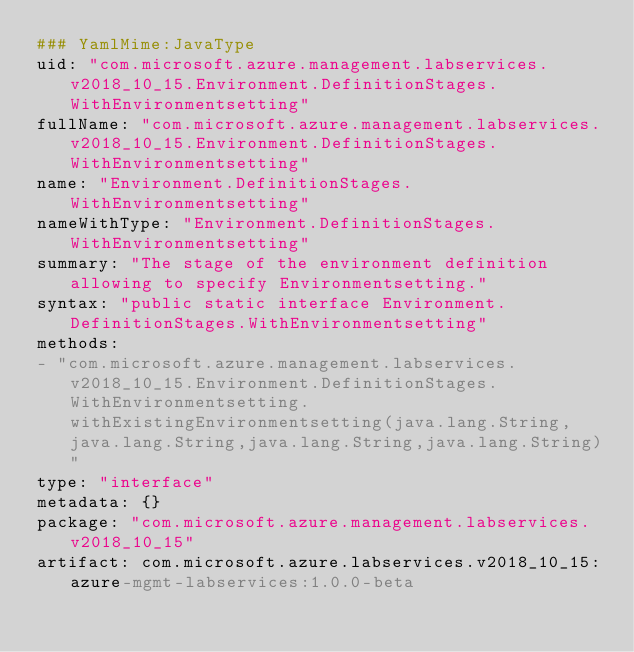<code> <loc_0><loc_0><loc_500><loc_500><_YAML_>### YamlMime:JavaType
uid: "com.microsoft.azure.management.labservices.v2018_10_15.Environment.DefinitionStages.WithEnvironmentsetting"
fullName: "com.microsoft.azure.management.labservices.v2018_10_15.Environment.DefinitionStages.WithEnvironmentsetting"
name: "Environment.DefinitionStages.WithEnvironmentsetting"
nameWithType: "Environment.DefinitionStages.WithEnvironmentsetting"
summary: "The stage of the environment definition allowing to specify Environmentsetting."
syntax: "public static interface Environment.DefinitionStages.WithEnvironmentsetting"
methods:
- "com.microsoft.azure.management.labservices.v2018_10_15.Environment.DefinitionStages.WithEnvironmentsetting.withExistingEnvironmentsetting(java.lang.String,java.lang.String,java.lang.String,java.lang.String)"
type: "interface"
metadata: {}
package: "com.microsoft.azure.management.labservices.v2018_10_15"
artifact: com.microsoft.azure.labservices.v2018_10_15:azure-mgmt-labservices:1.0.0-beta
</code> 